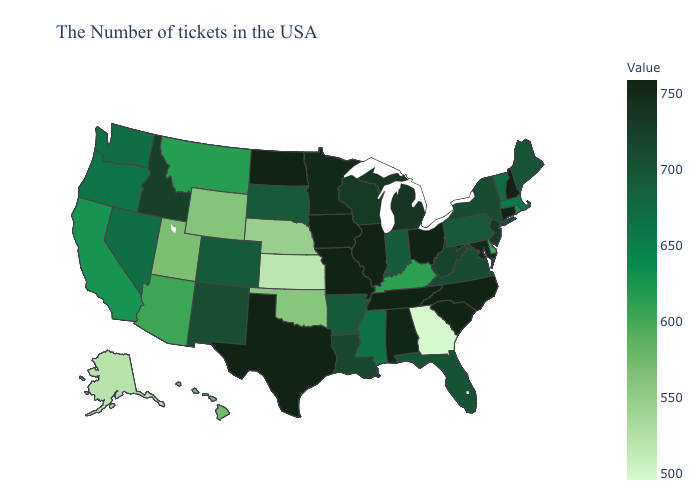Among the states that border Illinois , which have the lowest value?
Concise answer only. Kentucky. Does Ohio have the highest value in the USA?
Write a very short answer. Yes. Among the states that border Utah , does Nevada have the highest value?
Write a very short answer. No. Does Maine have a lower value than Oregon?
Be succinct. No. Does the map have missing data?
Be succinct. No. 